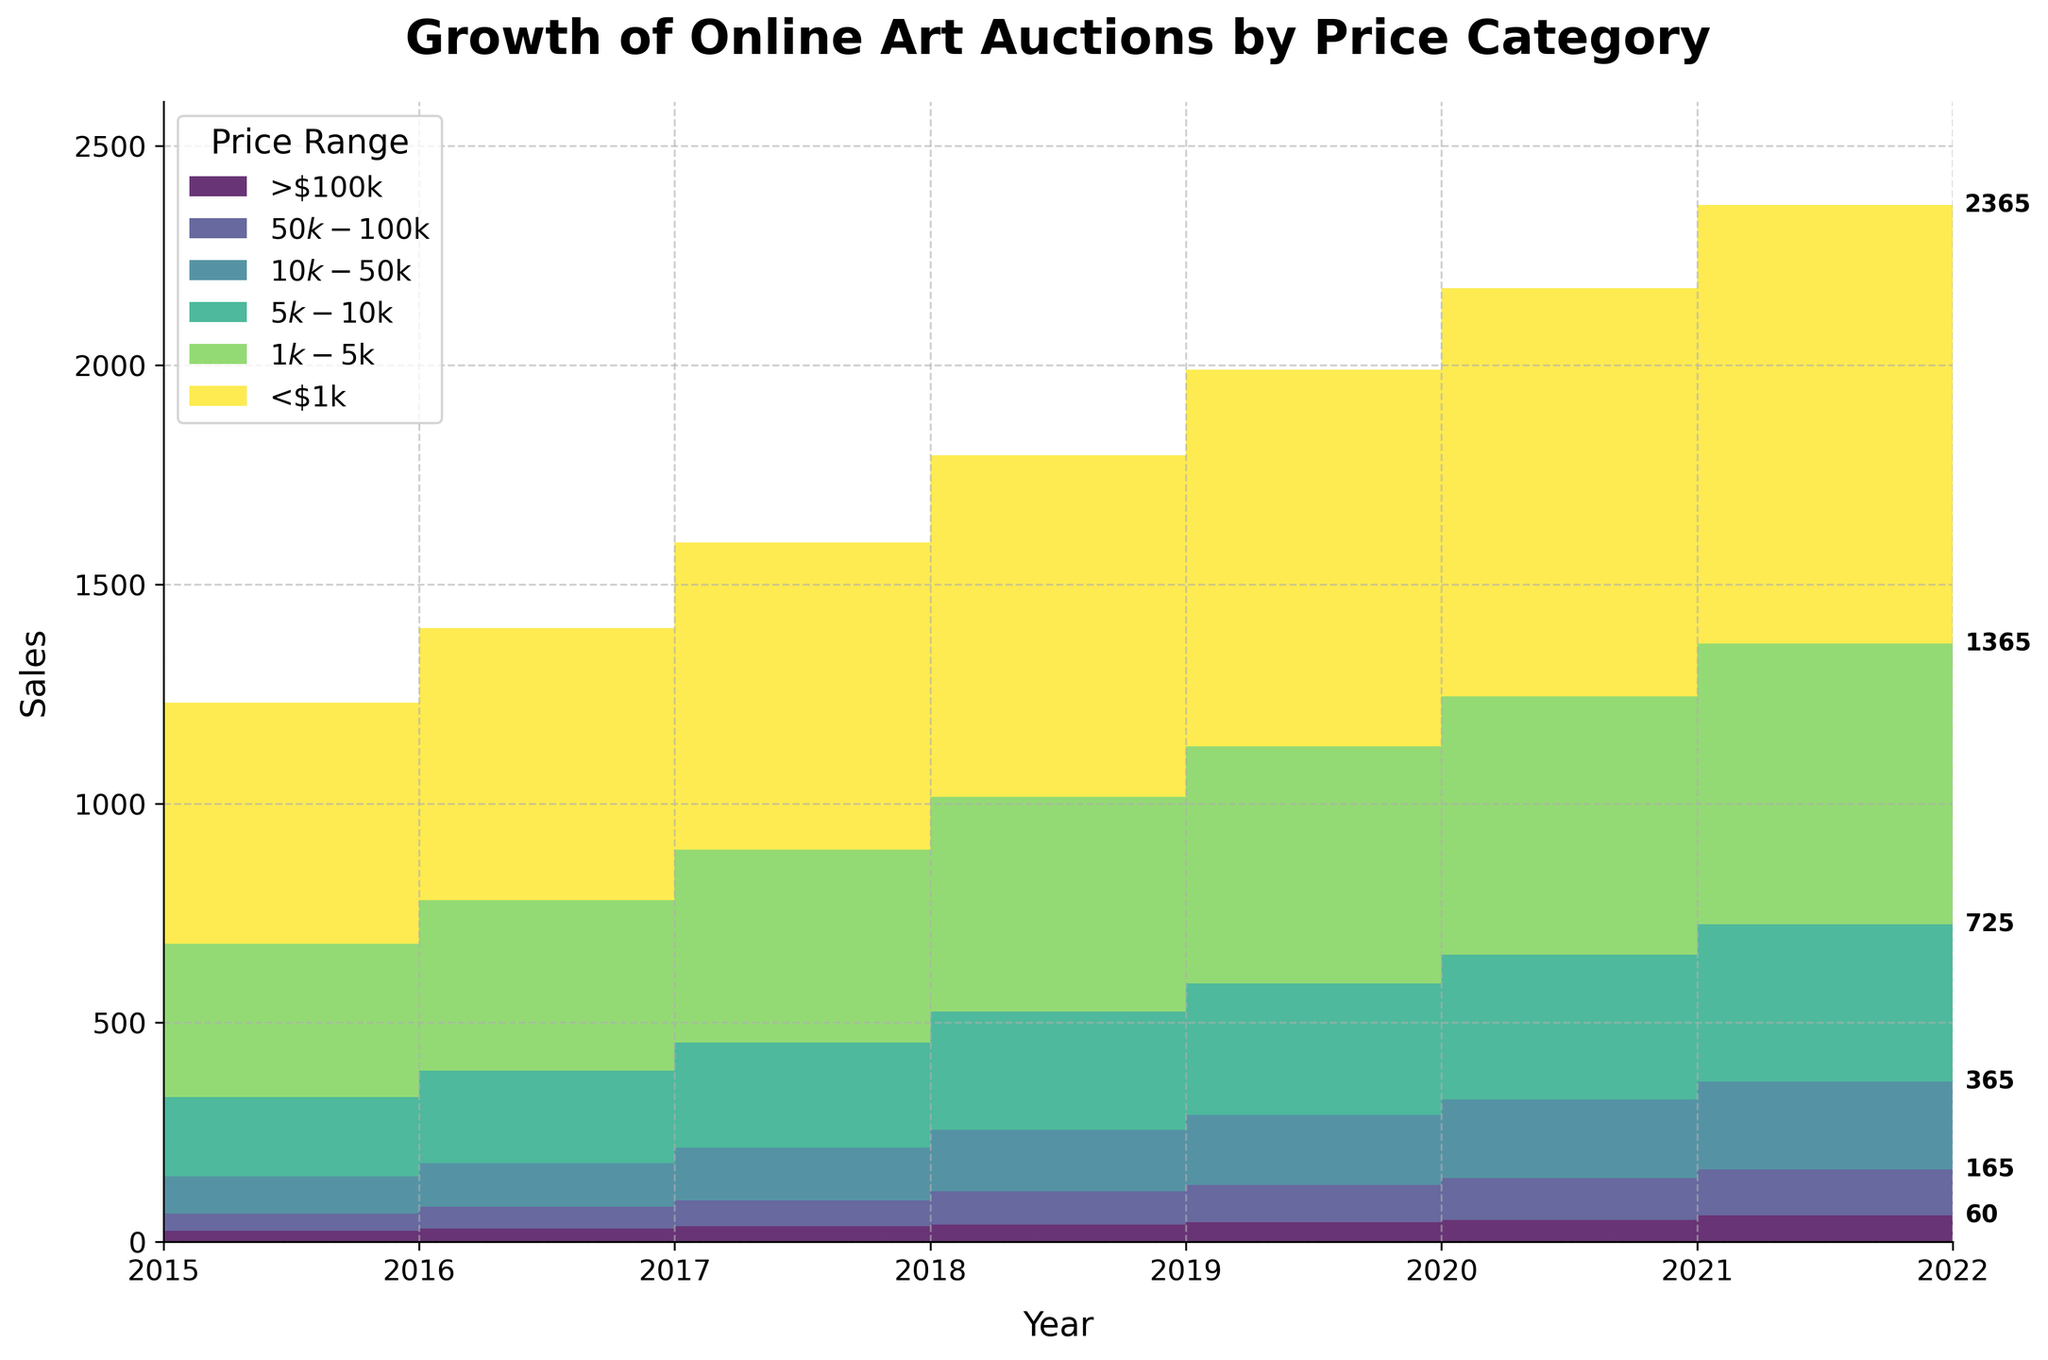What is the title of the chart? The title of the chart is written at the top and provides a summary of what the figure represents.
Answer: Growth of Online Art Auctions by Price Category What is the highest price range represented on the chart? The highest price range is indicated by the topmost area in the Step Area Chart.
Answer: >$100k In which year did the total sales for the <$1k price category first exceed 700? Look for the point in the chart where the area representing the <$1k price category surpasses 700 on the vertical axis.
Answer: 2018 What is the trend in the number of sales for the $10k-$50k price range from 2015 to 2022? Observe the changes in the area corresponding to the $10k-$50k price range from 2015 to 2022.
Answer: Increasing How many colors are used to represent the different price ranges? Count the distinct colors in the chart, each representing a price range.
Answer: Six Which price range saw the most consistent growth in sales over the years? Identify the area that steadily increases in size without fluctuations from 2015 to 2022.
Answer: <$1k What is the difference in total sales between the <$1k and $1k-$5k categories in 2022? Look at 2022 data for the <$1k and $1k-$5k categories and subtract the number of sales for the $1k-$5k category from the <$1k category.
Answer: 360 How do the total sales in 2017 for the $5k-$10k category compare to those in 2015? Check the sales numbers for the $5k-$10k category in both years and compare their values.
Answer: Higher in 2017 Which price category had the lowest sales in 2021 and what was the value? Find the smallest area at the end of 2021 and note its sales value.
Answer: >$100k, 50 What was the sales growth for the >$100k category from 2015 to 2020? Subtract the 2015 sales value from the 2020 sales value for the >$100k category.
Answer: 25 